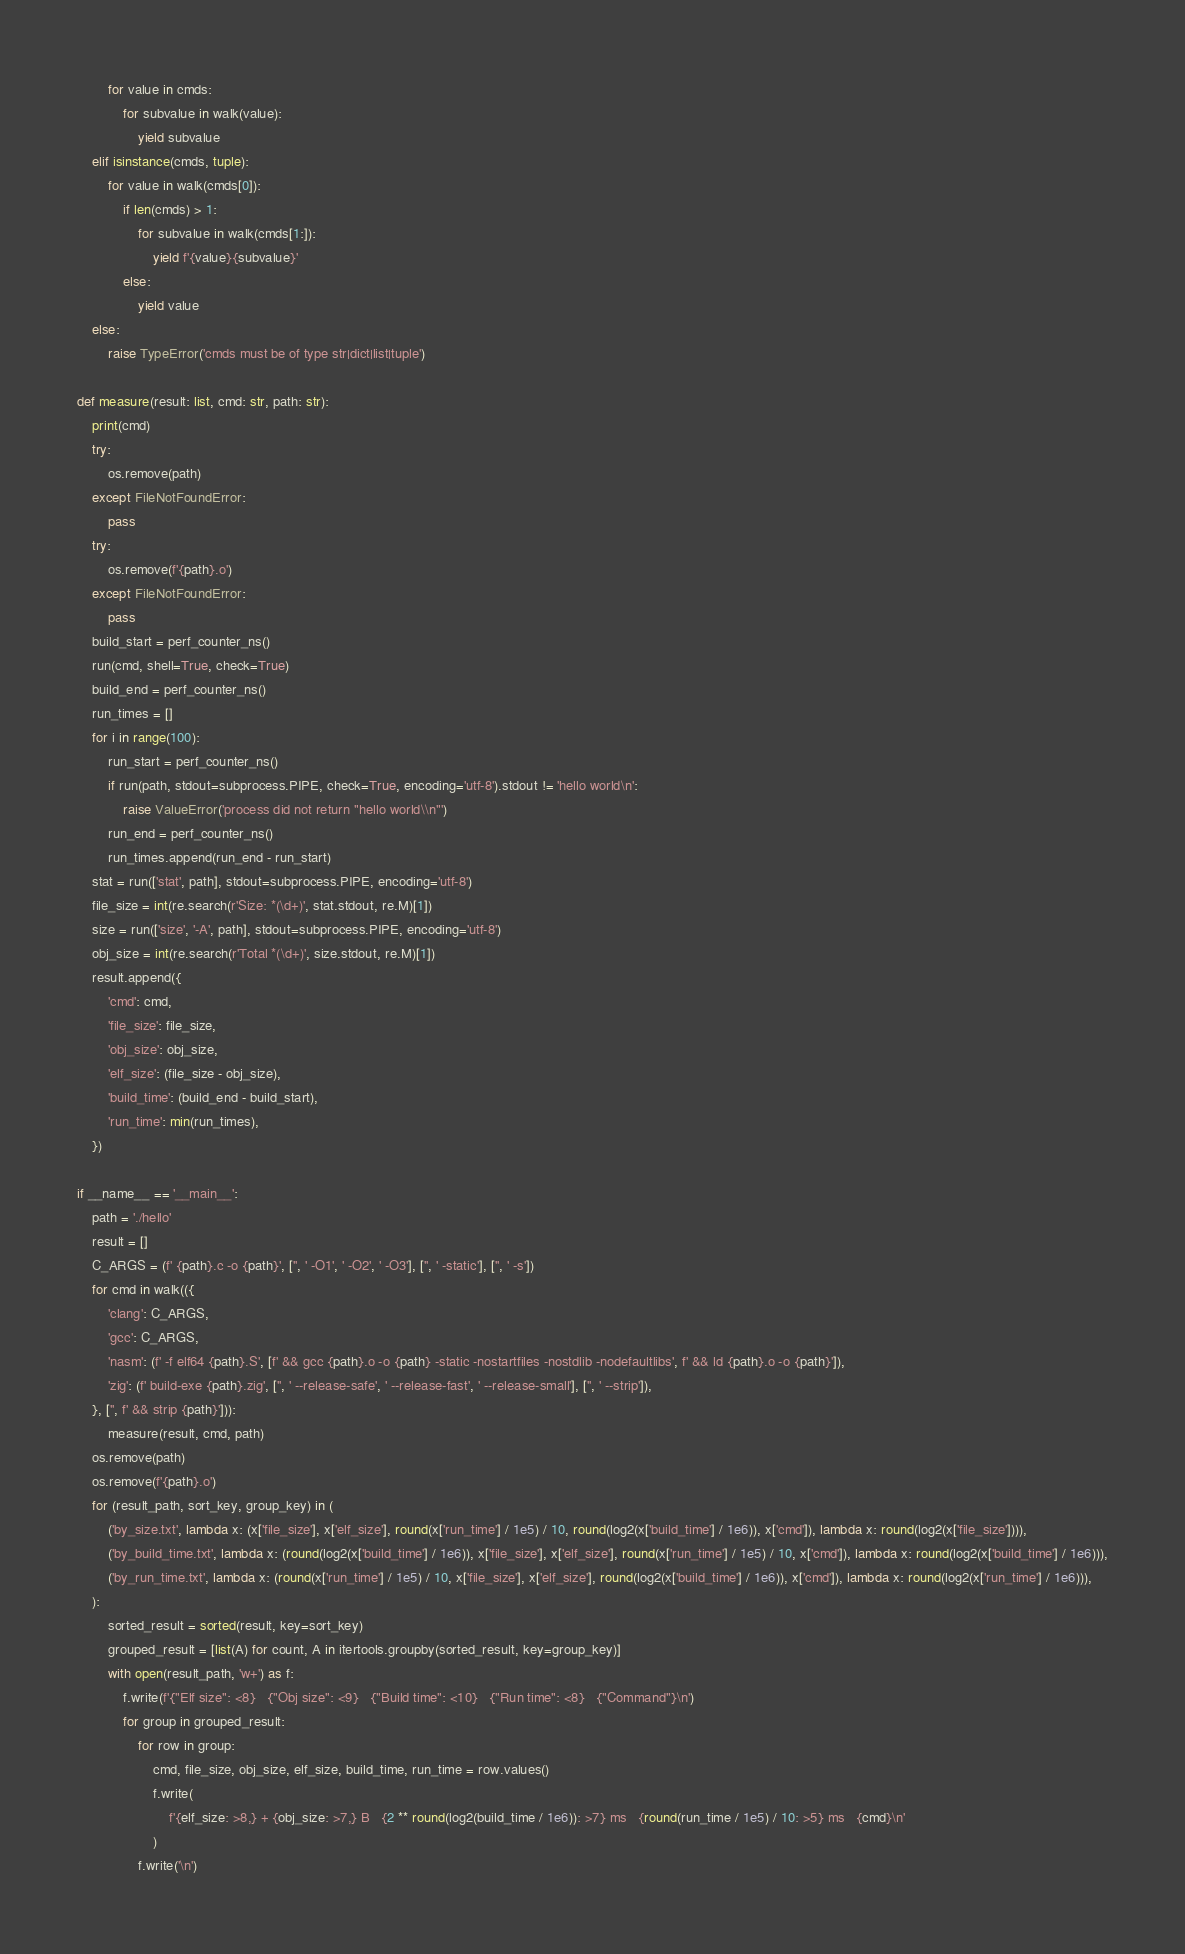<code> <loc_0><loc_0><loc_500><loc_500><_Python_>		for value in cmds:
			for subvalue in walk(value):
				yield subvalue
	elif isinstance(cmds, tuple):
		for value in walk(cmds[0]):
			if len(cmds) > 1:
				for subvalue in walk(cmds[1:]):
					yield f'{value}{subvalue}'
			else:
				yield value
	else:
		raise TypeError('cmds must be of type str|dict|list|tuple')

def measure(result: list, cmd: str, path: str):
	print(cmd)
	try:
		os.remove(path)
	except FileNotFoundError:
		pass
	try:
		os.remove(f'{path}.o')
	except FileNotFoundError:
		pass
	build_start = perf_counter_ns()
	run(cmd, shell=True, check=True)
	build_end = perf_counter_ns()
	run_times = []
	for i in range(100):
		run_start = perf_counter_ns()
		if run(path, stdout=subprocess.PIPE, check=True, encoding='utf-8').stdout != 'hello world\n':
			raise ValueError('process did not return "hello world\\n"')
		run_end = perf_counter_ns()
		run_times.append(run_end - run_start)
	stat = run(['stat', path], stdout=subprocess.PIPE, encoding='utf-8')
	file_size = int(re.search(r'Size: *(\d+)', stat.stdout, re.M)[1])
	size = run(['size', '-A', path], stdout=subprocess.PIPE, encoding='utf-8')
	obj_size = int(re.search(r'Total *(\d+)', size.stdout, re.M)[1])
	result.append({
		'cmd': cmd,
		'file_size': file_size,
		'obj_size': obj_size,
		'elf_size': (file_size - obj_size),
		'build_time': (build_end - build_start),
		'run_time': min(run_times),
	})

if __name__ == '__main__':
	path = './hello'
	result = []
	C_ARGS = (f' {path}.c -o {path}', ['', ' -O1', ' -O2', ' -O3'], ['', ' -static'], ['', ' -s'])
	for cmd in walk(({
		'clang': C_ARGS,
		'gcc': C_ARGS,
		'nasm': (f' -f elf64 {path}.S', [f' && gcc {path}.o -o {path} -static -nostartfiles -nostdlib -nodefaultlibs', f' && ld {path}.o -o {path}']),
		'zig': (f' build-exe {path}.zig', ['', ' --release-safe', ' --release-fast', ' --release-small'], ['', ' --strip']),
	}, ['', f' && strip {path}'])):
		measure(result, cmd, path)
	os.remove(path)
	os.remove(f'{path}.o')
	for (result_path, sort_key, group_key) in (
		('by_size.txt', lambda x: (x['file_size'], x['elf_size'], round(x['run_time'] / 1e5) / 10, round(log2(x['build_time'] / 1e6)), x['cmd']), lambda x: round(log2(x['file_size']))),
		('by_build_time.txt', lambda x: (round(log2(x['build_time'] / 1e6)), x['file_size'], x['elf_size'], round(x['run_time'] / 1e5) / 10, x['cmd']), lambda x: round(log2(x['build_time'] / 1e6))),
		('by_run_time.txt', lambda x: (round(x['run_time'] / 1e5) / 10, x['file_size'], x['elf_size'], round(log2(x['build_time'] / 1e6)), x['cmd']), lambda x: round(log2(x['run_time'] / 1e6))),
	):
		sorted_result = sorted(result, key=sort_key)
		grouped_result = [list(A) for count, A in itertools.groupby(sorted_result, key=group_key)]
		with open(result_path, 'w+') as f:
			f.write(f'{"Elf size": <8}   {"Obj size": <9}   {"Build time": <10}   {"Run time": <8}   {"Command"}\n')
			for group in grouped_result:
				for row in group:
					cmd, file_size, obj_size, elf_size, build_time, run_time = row.values()
					f.write(
					    f'{elf_size: >8,} + {obj_size: >7,} B   {2 ** round(log2(build_time / 1e6)): >7} ms   {round(run_time / 1e5) / 10: >5} ms   {cmd}\n'
					)
				f.write('\n')
</code> 